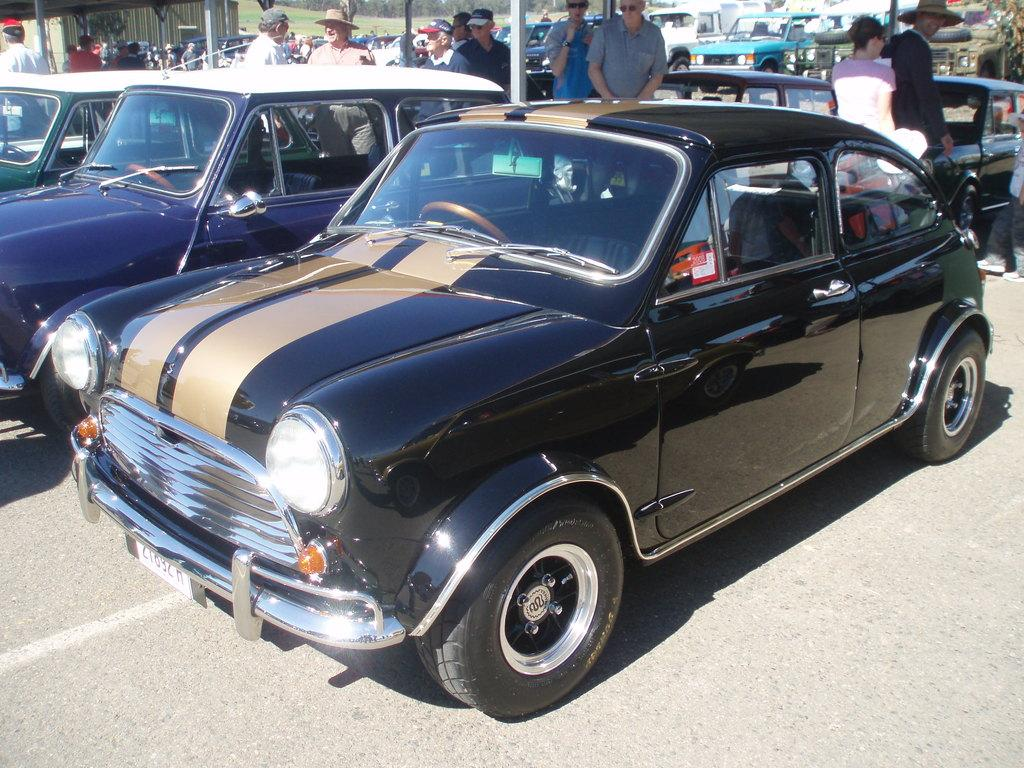What is the main feature of the image? There is a road in the image. What is happening on the road? There are cars and people on the road. What else can be seen in the image besides the road and its occupants? There are rods visible in the image. Is there any structure visible in the image? Yes, there is a building in the top left corner of the image. Can you tell me how many porters are carrying scissors in the image? There are no porters or scissors present in the image. What type of town is depicted in the image? The image does not depict a town; it features a road, cars, people, rods, and a building. 